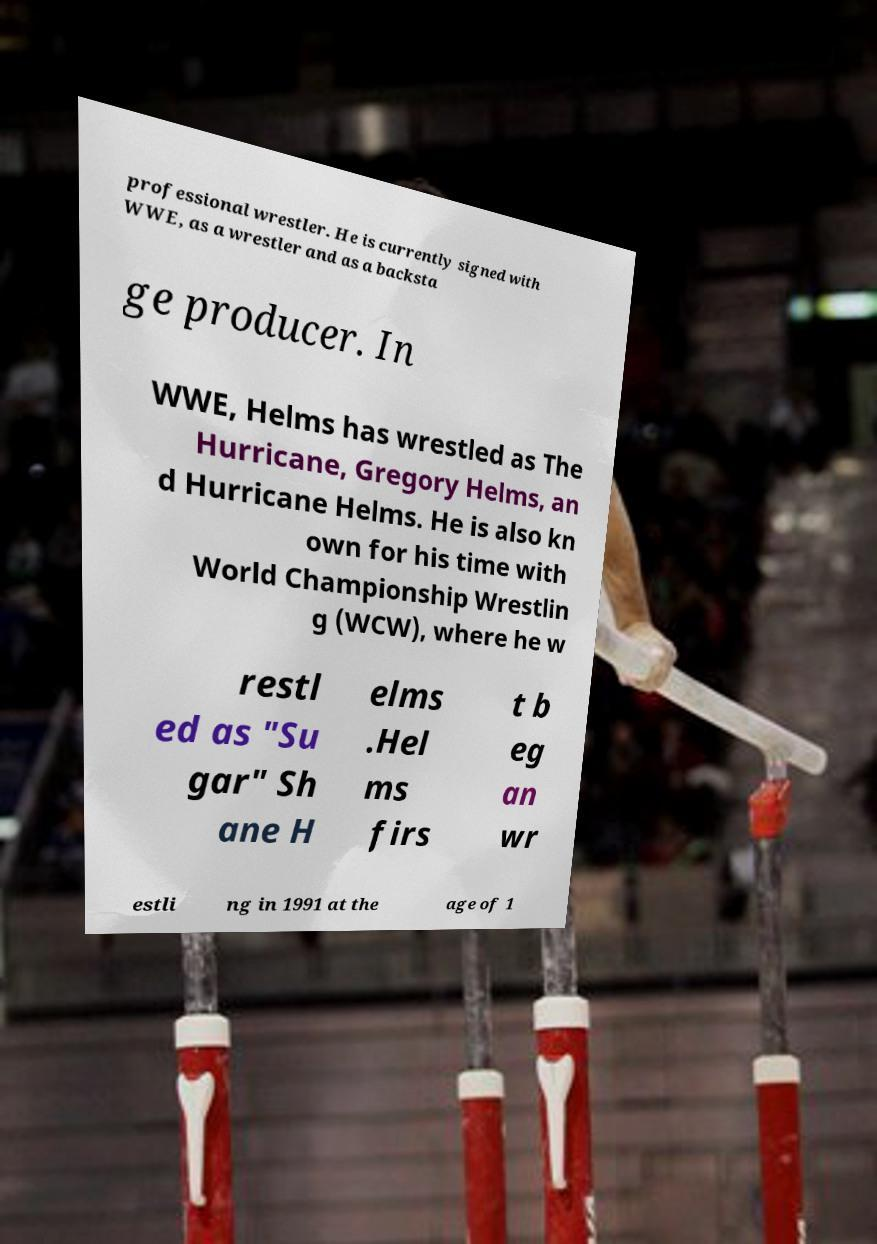For documentation purposes, I need the text within this image transcribed. Could you provide that? professional wrestler. He is currently signed with WWE, as a wrestler and as a backsta ge producer. In WWE, Helms has wrestled as The Hurricane, Gregory Helms, an d Hurricane Helms. He is also kn own for his time with World Championship Wrestlin g (WCW), where he w restl ed as "Su gar" Sh ane H elms .Hel ms firs t b eg an wr estli ng in 1991 at the age of 1 